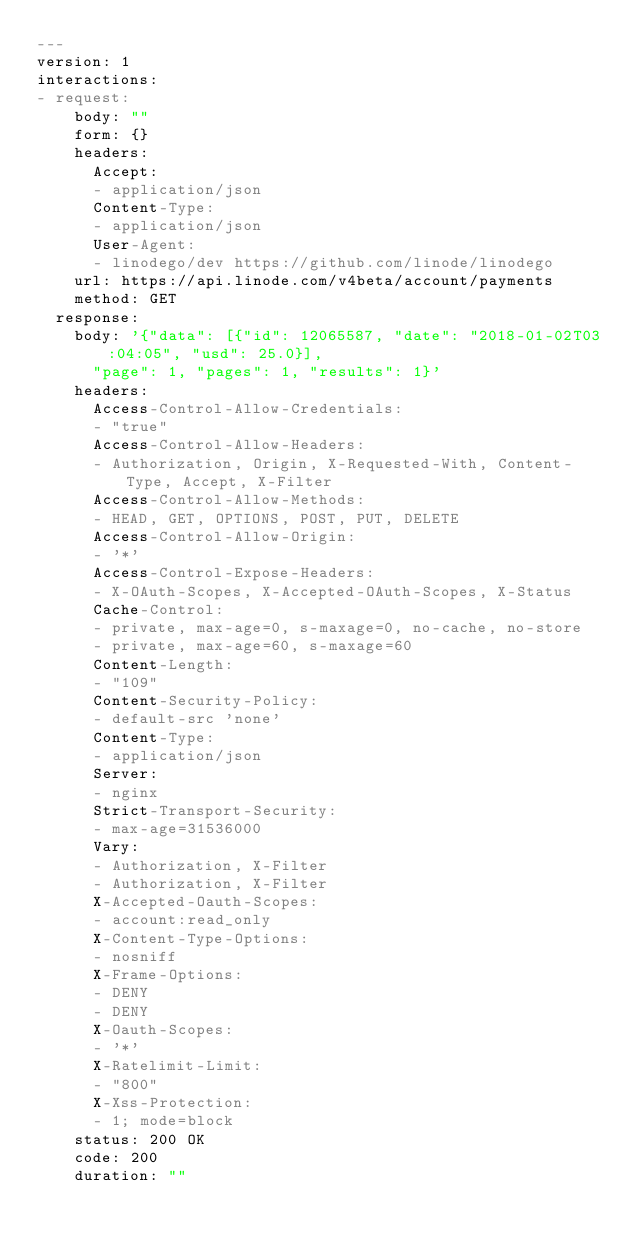<code> <loc_0><loc_0><loc_500><loc_500><_YAML_>---
version: 1
interactions:
- request:
    body: ""
    form: {}
    headers:
      Accept:
      - application/json
      Content-Type:
      - application/json
      User-Agent:
      - linodego/dev https://github.com/linode/linodego
    url: https://api.linode.com/v4beta/account/payments
    method: GET
  response:
    body: '{"data": [{"id": 12065587, "date": "2018-01-02T03:04:05", "usd": 25.0}],
      "page": 1, "pages": 1, "results": 1}'
    headers:
      Access-Control-Allow-Credentials:
      - "true"
      Access-Control-Allow-Headers:
      - Authorization, Origin, X-Requested-With, Content-Type, Accept, X-Filter
      Access-Control-Allow-Methods:
      - HEAD, GET, OPTIONS, POST, PUT, DELETE
      Access-Control-Allow-Origin:
      - '*'
      Access-Control-Expose-Headers:
      - X-OAuth-Scopes, X-Accepted-OAuth-Scopes, X-Status
      Cache-Control:
      - private, max-age=0, s-maxage=0, no-cache, no-store
      - private, max-age=60, s-maxage=60
      Content-Length:
      - "109"
      Content-Security-Policy:
      - default-src 'none'
      Content-Type:
      - application/json
      Server:
      - nginx
      Strict-Transport-Security:
      - max-age=31536000
      Vary:
      - Authorization, X-Filter
      - Authorization, X-Filter
      X-Accepted-Oauth-Scopes:
      - account:read_only
      X-Content-Type-Options:
      - nosniff
      X-Frame-Options:
      - DENY
      - DENY
      X-Oauth-Scopes:
      - '*'
      X-Ratelimit-Limit:
      - "800"
      X-Xss-Protection:
      - 1; mode=block
    status: 200 OK
    code: 200
    duration: ""
</code> 